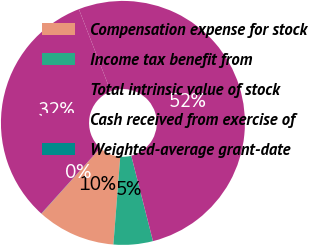<chart> <loc_0><loc_0><loc_500><loc_500><pie_chart><fcel>Compensation expense for stock<fcel>Income tax benefit from<fcel>Total intrinsic value of stock<fcel>Cash received from exercise of<fcel>Weighted-average grant-date<nl><fcel>10.4%<fcel>5.21%<fcel>51.92%<fcel>32.46%<fcel>0.02%<nl></chart> 